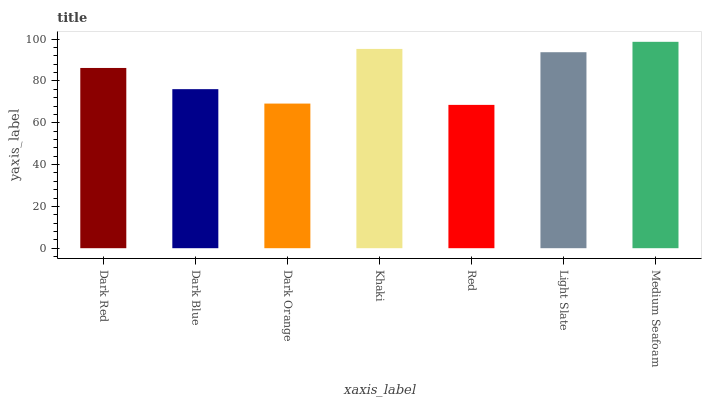Is Red the minimum?
Answer yes or no. Yes. Is Medium Seafoam the maximum?
Answer yes or no. Yes. Is Dark Blue the minimum?
Answer yes or no. No. Is Dark Blue the maximum?
Answer yes or no. No. Is Dark Red greater than Dark Blue?
Answer yes or no. Yes. Is Dark Blue less than Dark Red?
Answer yes or no. Yes. Is Dark Blue greater than Dark Red?
Answer yes or no. No. Is Dark Red less than Dark Blue?
Answer yes or no. No. Is Dark Red the high median?
Answer yes or no. Yes. Is Dark Red the low median?
Answer yes or no. Yes. Is Khaki the high median?
Answer yes or no. No. Is Medium Seafoam the low median?
Answer yes or no. No. 